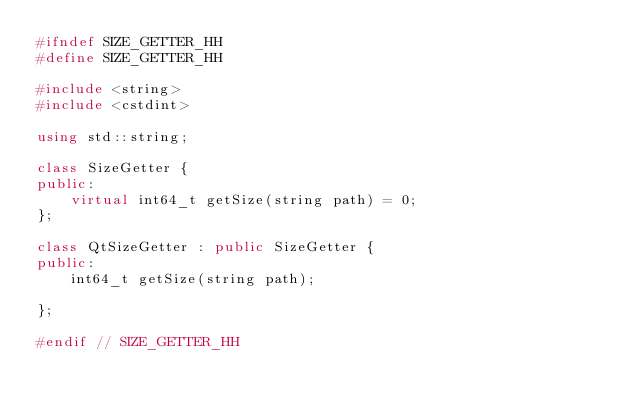Convert code to text. <code><loc_0><loc_0><loc_500><loc_500><_C++_>#ifndef SIZE_GETTER_HH
#define SIZE_GETTER_HH

#include <string>
#include <cstdint>

using std::string;

class SizeGetter {
public:
    virtual int64_t getSize(string path) = 0;
};

class QtSizeGetter : public SizeGetter {
public:
    int64_t getSize(string path);

};

#endif // SIZE_GETTER_HH
</code> 